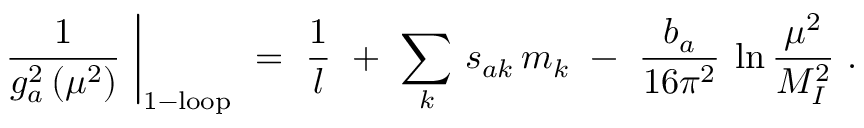Convert formula to latex. <formula><loc_0><loc_0><loc_500><loc_500>\frac { 1 } { g _ { a } ^ { 2 } \, ( \mu ^ { 2 } ) } \ \right | _ { 1 - l o o p } \ = \ \frac { 1 } { l } \ + \ \sum _ { k } \, s _ { a k } \, m _ { k } \ - \ \frac { b _ { a } } { 1 6 \pi ^ { 2 } } \, \ln \frac { \mu ^ { 2 } } { M _ { I } ^ { 2 } } \ .</formula> 